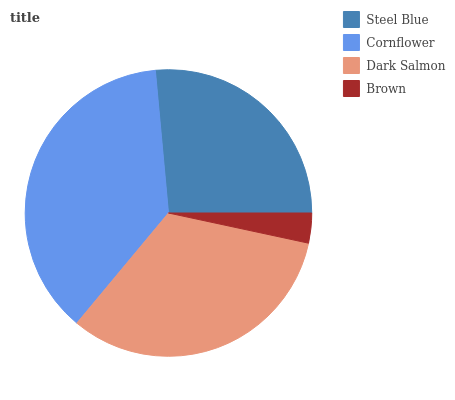Is Brown the minimum?
Answer yes or no. Yes. Is Cornflower the maximum?
Answer yes or no. Yes. Is Dark Salmon the minimum?
Answer yes or no. No. Is Dark Salmon the maximum?
Answer yes or no. No. Is Cornflower greater than Dark Salmon?
Answer yes or no. Yes. Is Dark Salmon less than Cornflower?
Answer yes or no. Yes. Is Dark Salmon greater than Cornflower?
Answer yes or no. No. Is Cornflower less than Dark Salmon?
Answer yes or no. No. Is Dark Salmon the high median?
Answer yes or no. Yes. Is Steel Blue the low median?
Answer yes or no. Yes. Is Steel Blue the high median?
Answer yes or no. No. Is Cornflower the low median?
Answer yes or no. No. 